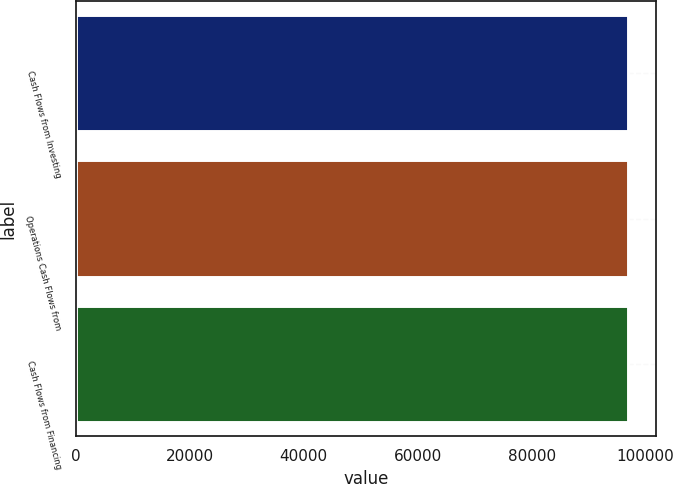<chart> <loc_0><loc_0><loc_500><loc_500><bar_chart><fcel>Cash Flows from Investing<fcel>Operations Cash Flows from<fcel>Cash Flows from Financing<nl><fcel>96910<fcel>96910.1<fcel>96910.2<nl></chart> 